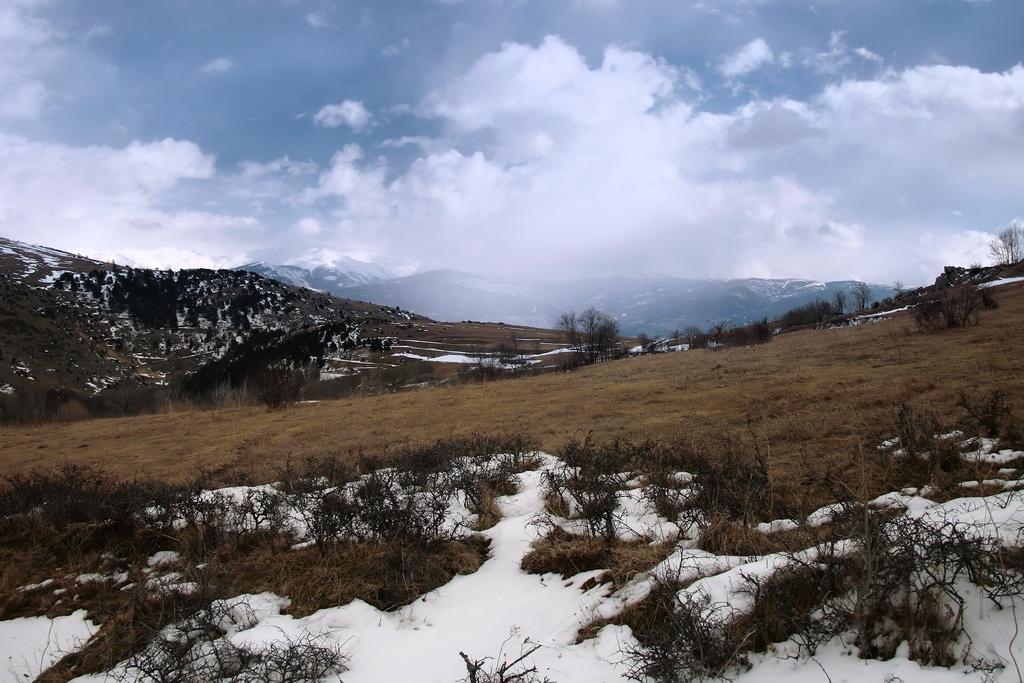Can you describe this image briefly? In this image there is a mountain area and it is covered with snow, in the background there are mountains and sky. 